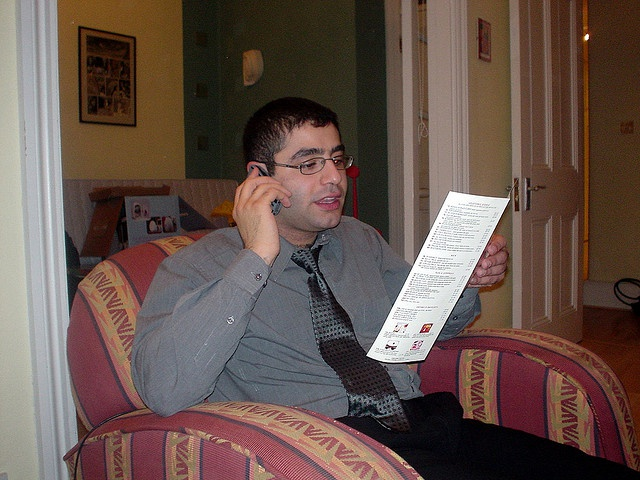Describe the objects in this image and their specific colors. I can see people in darkgray, gray, and black tones, chair in darkgray, maroon, and brown tones, tie in darkgray, black, gray, and purple tones, and cell phone in darkgray, gray, and black tones in this image. 